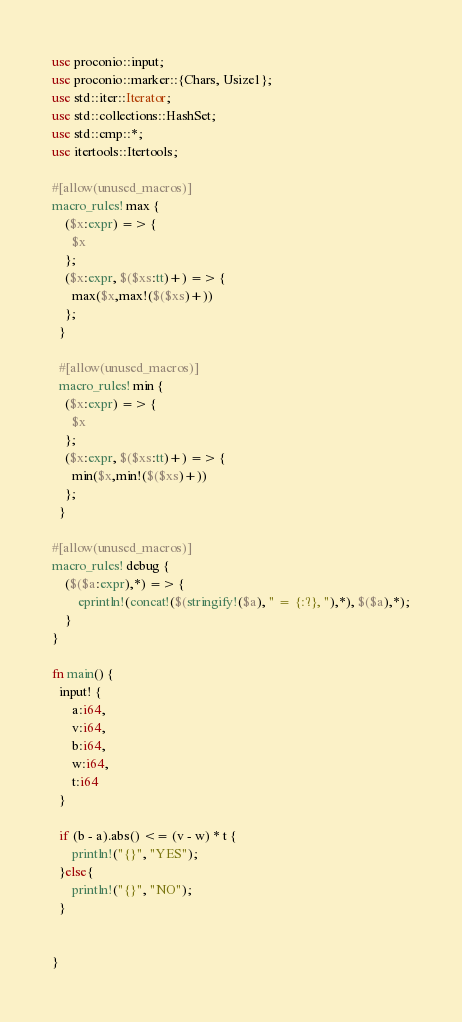<code> <loc_0><loc_0><loc_500><loc_500><_Rust_>use proconio::input;
use proconio::marker::{Chars, Usize1};
use std::iter::Iterator;
use std::collections::HashSet;
use std::cmp::*;
use itertools::Itertools;

#[allow(unused_macros)]
macro_rules! max {
    ($x:expr) => {
      $x
    };
    ($x:expr, $($xs:tt)+) => {
      max($x,max!($($xs)+))
    };
  }
  
  #[allow(unused_macros)]
  macro_rules! min {
    ($x:expr) => {
      $x
    };
    ($x:expr, $($xs:tt)+) => {
      min($x,min!($($xs)+))
    };
  }

#[allow(unused_macros)]
macro_rules! debug {
    ($($a:expr),*) => {
        eprintln!(concat!($(stringify!($a), " = {:?}, "),*), $($a),*);
    }
}

fn main() {
  input! {
      a:i64, 
      v:i64,
      b:i64,
      w:i64,
      t:i64
  }

  if (b - a).abs() <= (v - w) * t {
      println!("{}", "YES");
  }else{
      println!("{}", "NO");
  }


}

</code> 